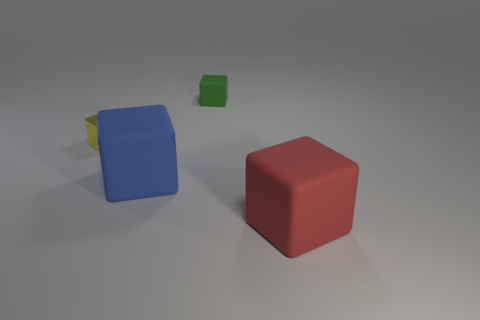Add 2 large cyan matte balls. How many objects exist? 6 Add 3 small yellow metal cylinders. How many small yellow metal cylinders exist? 3 Subtract 0 green balls. How many objects are left? 4 Subtract all tiny green objects. Subtract all green rubber cubes. How many objects are left? 2 Add 2 small shiny things. How many small shiny things are left? 3 